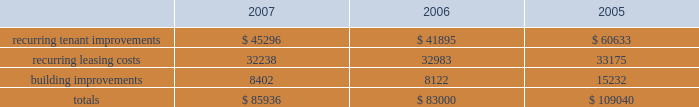In february 2008 , we issued $ 300.0 million of 8.375% ( 8.375 % ) series o cumulative redeemable preferred shares .
The indentures ( and related supplemental indentures ) governing our outstanding series of notes also require us to comply with financial ratios and other covenants regarding our operations .
We were in compliance with all such covenants as of december 31 , 2007 .
Sale of real estate assets we utilize sales of real estate assets as an additional source of liquidity .
We pursue opportunities to sell real estate assets at favorable prices to capture value created by us as well as to improve the overall quality of our portfolio by recycling sale proceeds into new properties with greater value creation opportunities .
Uses of liquidity our principal uses of liquidity include the following : 2022 property investments ; 2022 recurring leasing/capital costs ; 2022 dividends and distributions to shareholders and unitholders ; 2022 long-term debt maturities ; and 2022 other contractual obligations property investments we evaluate development and acquisition opportunities based upon market outlook , supply and long-term growth potential .
Recurring expenditures one of our principal uses of our liquidity is to fund the recurring leasing/capital expenditures of our real estate investments .
The following is a summary of our recurring capital expenditures for the years ended december 31 , 2007 , 2006 and 2005 , respectively ( in thousands ) : .
Dividends and distributions in order to qualify as a reit for federal income tax purposes , we must currently distribute at least 90% ( 90 % ) of our taxable income to shareholders .
We paid dividends per share of $ 1.91 , $ 1.89 and $ 1.87 for the years ended december 31 , 2007 , 2006 and 2005 , respectively .
We also paid a one-time special dividend of $ 1.05 per share in 2005 as a result of the significant gain realized from an industrial portfolio sale .
We expect to continue to distribute taxable earnings to meet the requirements to maintain our reit status .
However , distributions are declared at the discretion of our board of directors and are subject to actual cash available for distribution , our financial condition , capital requirements and such other factors as our board of directors deems relevant .
Debt maturities debt outstanding at december 31 , 2007 totaled $ 4.3 billion with a weighted average interest rate of 5.74% ( 5.74 % ) maturing at various dates through 2028 .
We had $ 3.2 billion of unsecured notes , $ 546.1 million outstanding on our unsecured lines of credit and $ 524.4 million of secured debt outstanding at december 31 , 2007 .
Scheduled principal amortization and maturities of such debt totaled $ 249.8 million for the year ended december 31 , 2007 and $ 146.4 million of secured debt was transferred to unconsolidated subsidiaries in connection with the contribution of properties in 2007. .
What was the percent of the increase in the dividends paid per share from 2006 to 2007? 
Computations: ((1.91 - 1.89) / 1.89)
Answer: 0.01058. 